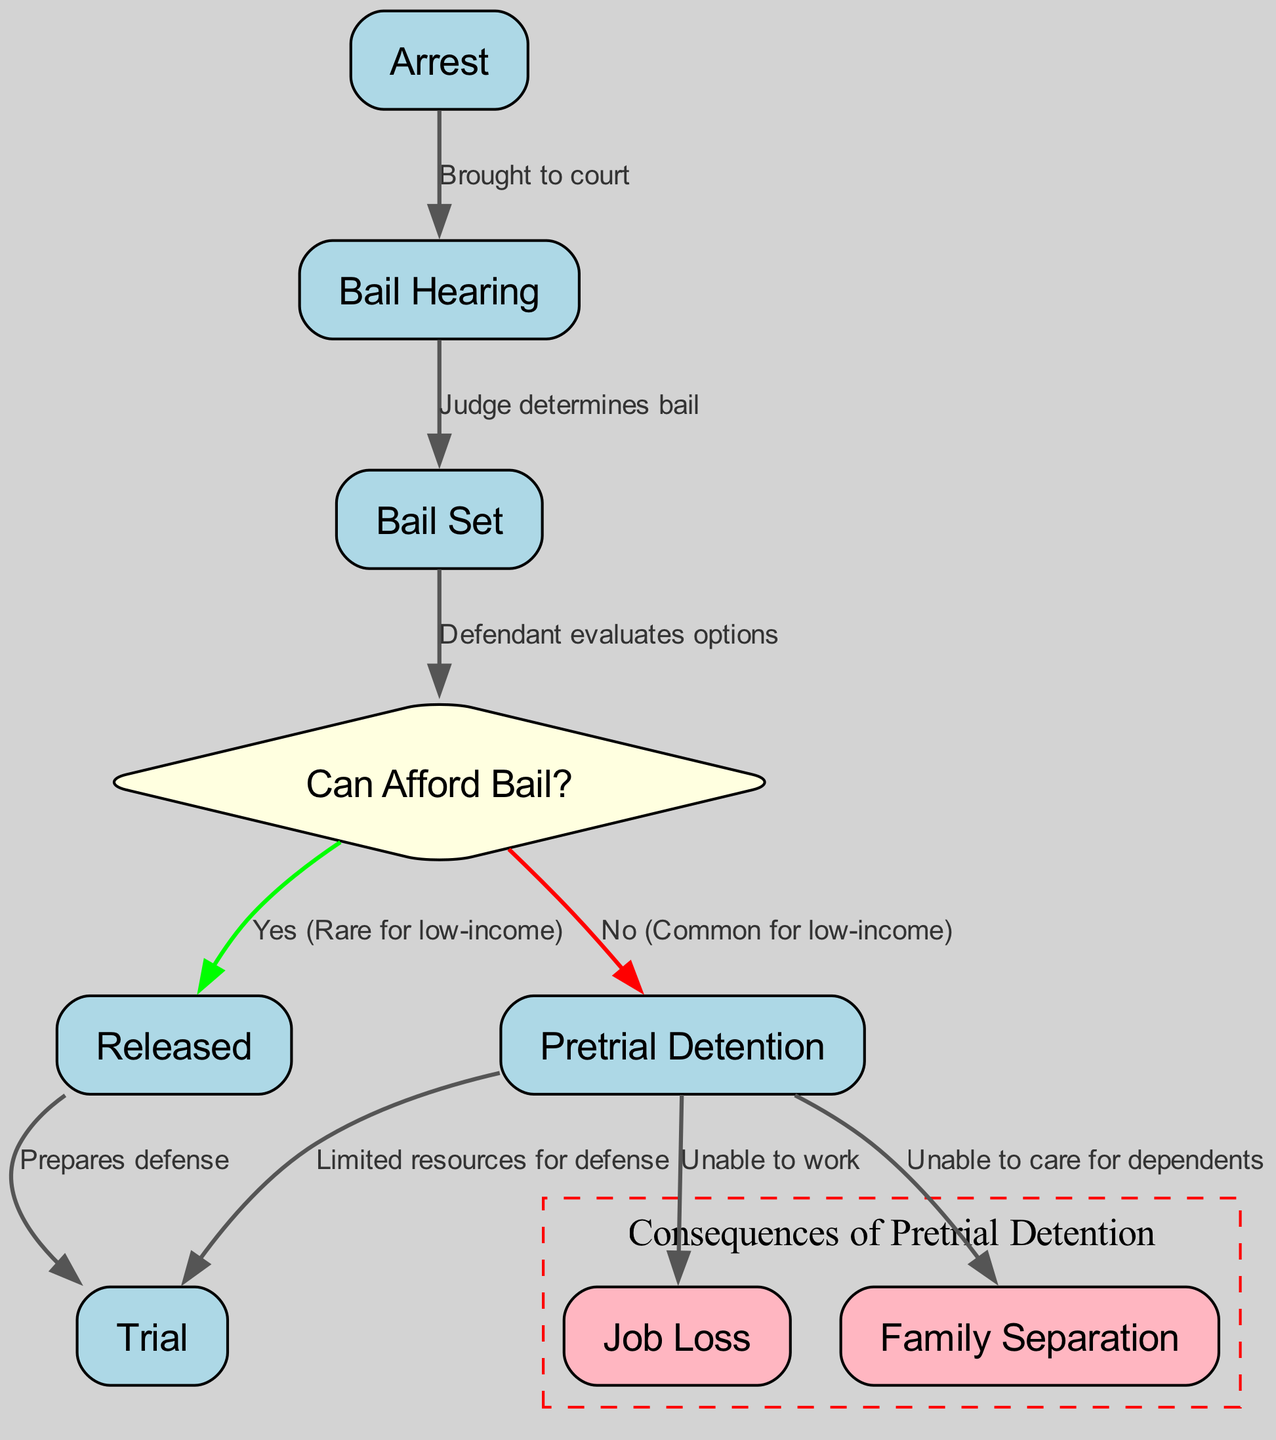What is the first node in the diagram? The first node represents the starting point of the flowchart, which is labeled "Arrest." This indicates that the process begins with an arrest.
Answer: Arrest How many edges originate from the "Bail Hearing" node? The "Bail Hearing" node has two edges leading from it, one directed to "Bail Set" and the other to "Can Afford Bail?" This shows the connections stemming from this decision point.
Answer: 2 What happens if a low-income defendant cannot afford bail? If a low-income defendant cannot afford bail, they move to the "Pretrial Detention" node. This indicates the common outcome for low-income defendants when bail is not affordable.
Answer: Pretrial Detention What are the consequences of pretrial detention listed in the diagram? The consequences listed are "Job Loss" and "Family Separation." These outcomes highlight the serious impacts that pretrial detention can have on low-income defendants and their families.
Answer: Job Loss, Family Separation What is the relationship between "Released" and "Trial"? The diagram shows that if a defendant is "Released," they can proceed to "Trial" while being able to prepare their defense, as indicated by the connection from "Released" to "Trial."
Answer: Prepares defense What signifies the decision point in the diagram? The decision point in the diagram is represented by the diamond-shaped node "Can Afford Bail?" This signifies where an evaluation occurs regarding the ability to pay bail.
Answer: Can Afford Bail? What does "Yes (Rare for low-income)" lead to in the flowchart? "Yes (Rare for low-income)" leads directly to the "Released" node. This indicates that upon determining they can afford bail, a low-income defendant would typically be released, although this is noted as rare.
Answer: Released What is the outcome of pretrial detention in terms of resources for defense? The outcome of pretrial detention indicates "Limited resources for defense." This points out the challenges faced by those who are detained pretrial in mounting an effective legal defense.
Answer: Limited resources for defense 